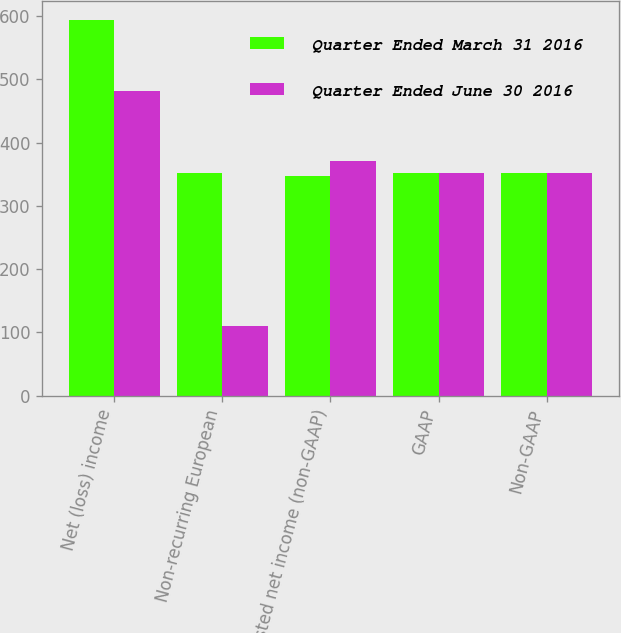Convert chart to OTSL. <chart><loc_0><loc_0><loc_500><loc_500><stacked_bar_chart><ecel><fcel>Net (loss) income<fcel>Non-recurring European<fcel>Adjusted net income (non-GAAP)<fcel>GAAP<fcel>Non-GAAP<nl><fcel>Quarter Ended March 31 2016<fcel>594.6<fcel>351.6<fcel>348<fcel>351.3<fcel>351.9<nl><fcel>Quarter Ended June 30 2016<fcel>481.3<fcel>109.6<fcel>371.7<fcel>351.6<fcel>351.6<nl></chart> 